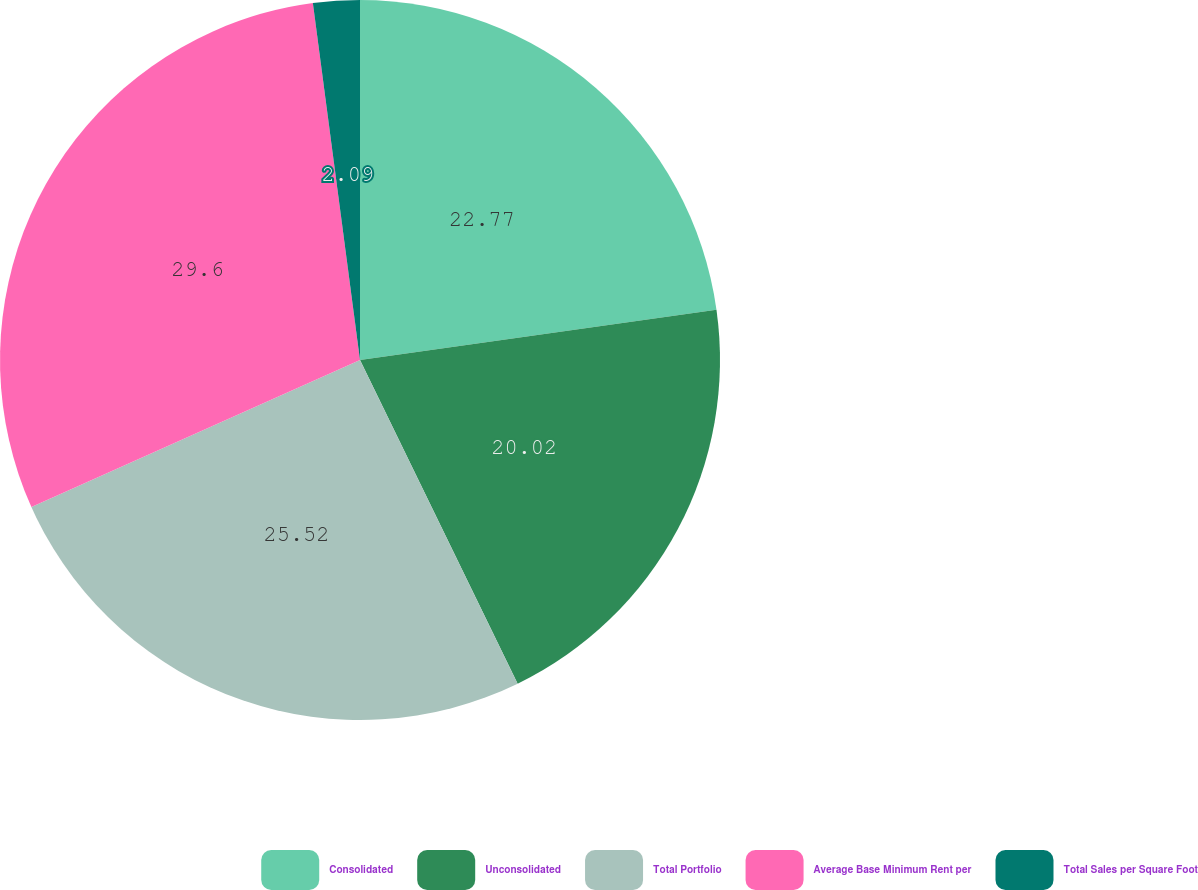Convert chart to OTSL. <chart><loc_0><loc_0><loc_500><loc_500><pie_chart><fcel>Consolidated<fcel>Unconsolidated<fcel>Total Portfolio<fcel>Average Base Minimum Rent per<fcel>Total Sales per Square Foot<nl><fcel>22.77%<fcel>20.02%<fcel>25.52%<fcel>29.61%<fcel>2.09%<nl></chart> 